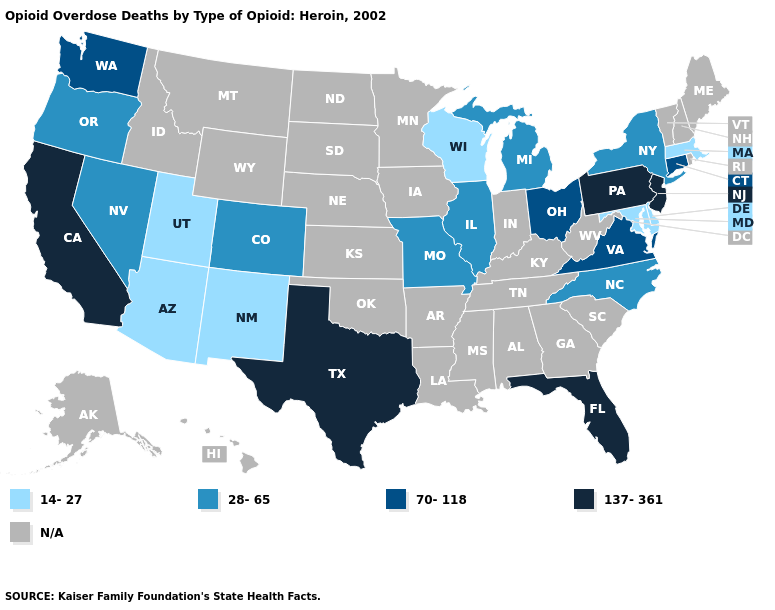What is the value of Missouri?
Be succinct. 28-65. Name the states that have a value in the range 137-361?
Short answer required. California, Florida, New Jersey, Pennsylvania, Texas. Name the states that have a value in the range 28-65?
Give a very brief answer. Colorado, Illinois, Michigan, Missouri, Nevada, New York, North Carolina, Oregon. Name the states that have a value in the range 70-118?
Give a very brief answer. Connecticut, Ohio, Virginia, Washington. Which states have the highest value in the USA?
Be succinct. California, Florida, New Jersey, Pennsylvania, Texas. What is the highest value in the MidWest ?
Give a very brief answer. 70-118. What is the value of Maryland?
Be succinct. 14-27. What is the value of Vermont?
Keep it brief. N/A. Does Maryland have the lowest value in the USA?
Give a very brief answer. Yes. Among the states that border Rhode Island , does Connecticut have the lowest value?
Give a very brief answer. No. Among the states that border Wyoming , which have the lowest value?
Be succinct. Utah. Among the states that border Tennessee , which have the lowest value?
Write a very short answer. Missouri, North Carolina. Is the legend a continuous bar?
Answer briefly. No. Name the states that have a value in the range 70-118?
Be succinct. Connecticut, Ohio, Virginia, Washington. 